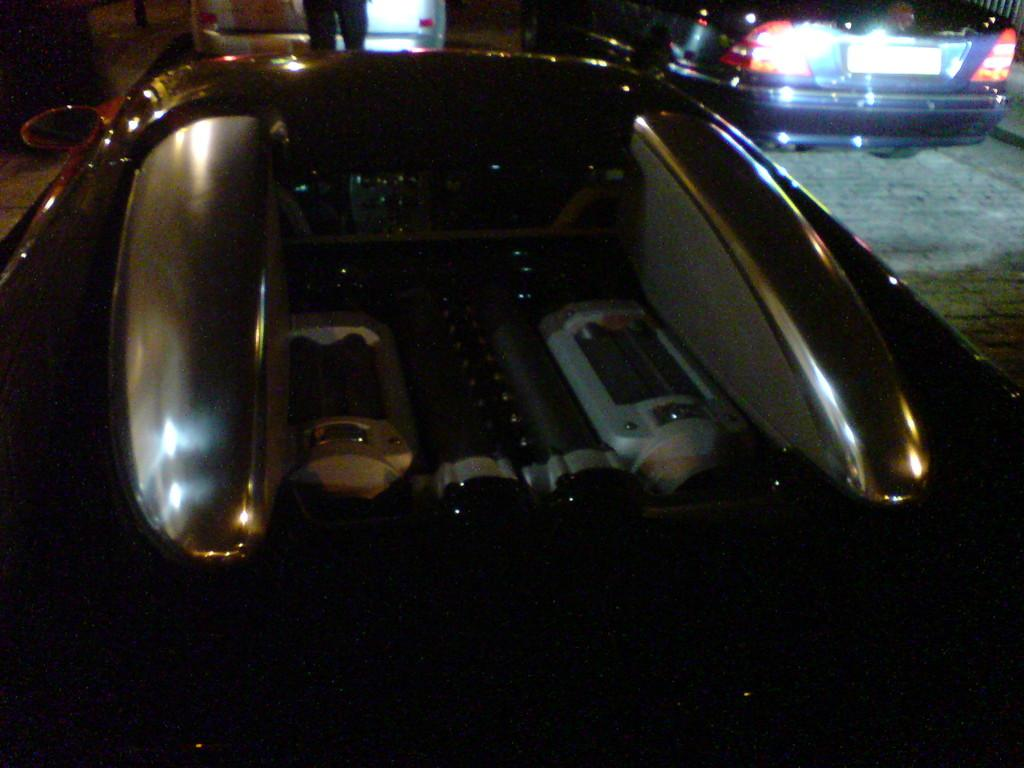What type of vehicles can be seen in the image? There are cars in the image. Can you describe the human in the image? There is a human in the image, but no specific details are provided about their appearance or actions. What color beads can be seen hanging from the car in the image? There are no beads present in the image; it features cars and a human. What type of company is depicted in the image? There is no company depicted in the image; it only shows cars and a human. 